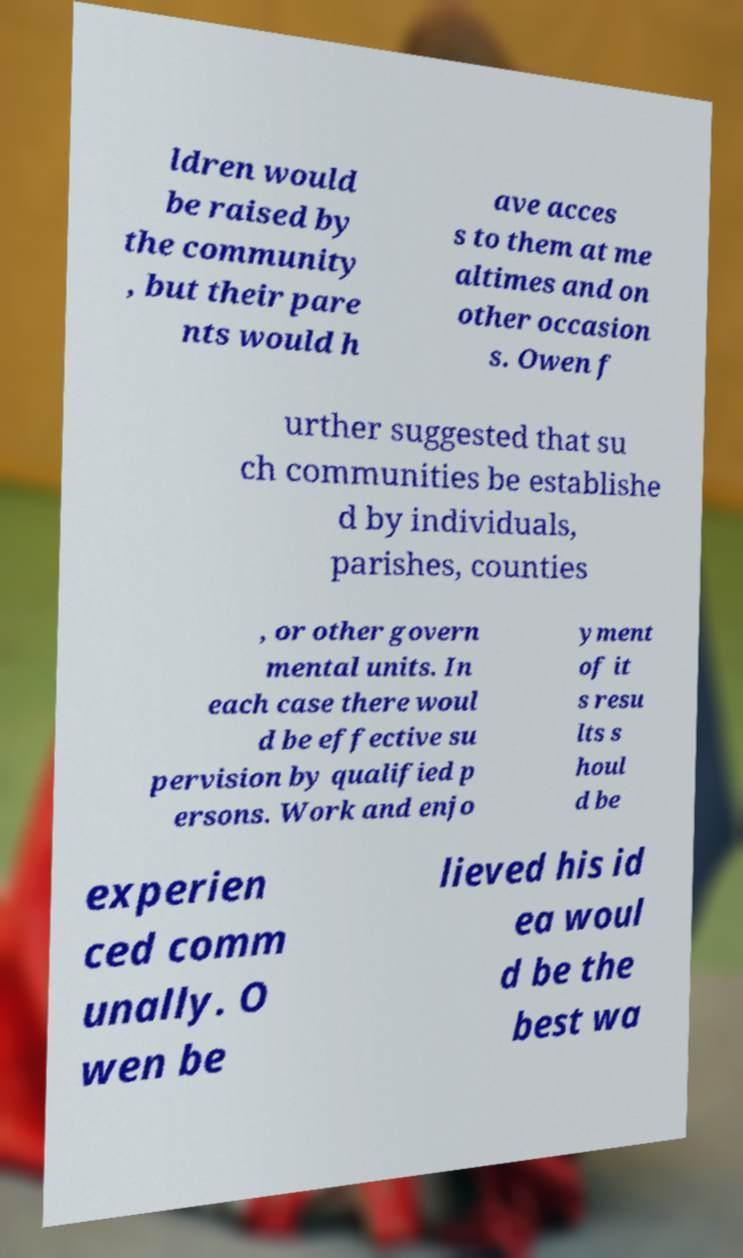Could you extract and type out the text from this image? ldren would be raised by the community , but their pare nts would h ave acces s to them at me altimes and on other occasion s. Owen f urther suggested that su ch communities be establishe d by individuals, parishes, counties , or other govern mental units. In each case there woul d be effective su pervision by qualified p ersons. Work and enjo yment of it s resu lts s houl d be experien ced comm unally. O wen be lieved his id ea woul d be the best wa 